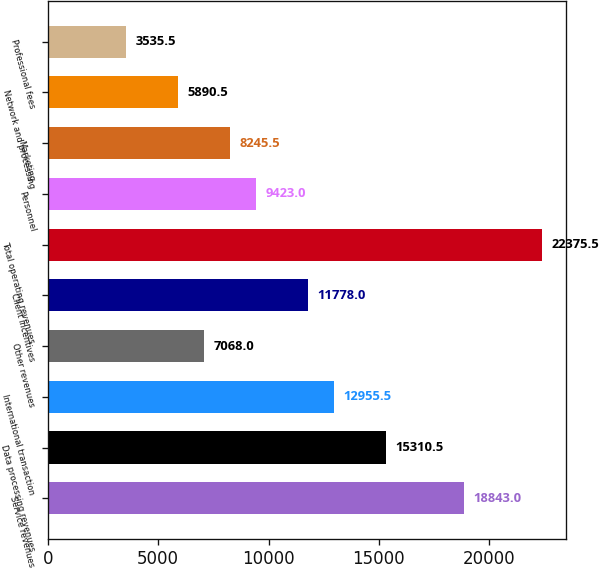<chart> <loc_0><loc_0><loc_500><loc_500><bar_chart><fcel>Service revenues<fcel>Data processing revenues<fcel>International transaction<fcel>Other revenues<fcel>Client incentives<fcel>Total operating revenues<fcel>Personnel<fcel>Marketing<fcel>Network and processing<fcel>Professional fees<nl><fcel>18843<fcel>15310.5<fcel>12955.5<fcel>7068<fcel>11778<fcel>22375.5<fcel>9423<fcel>8245.5<fcel>5890.5<fcel>3535.5<nl></chart> 